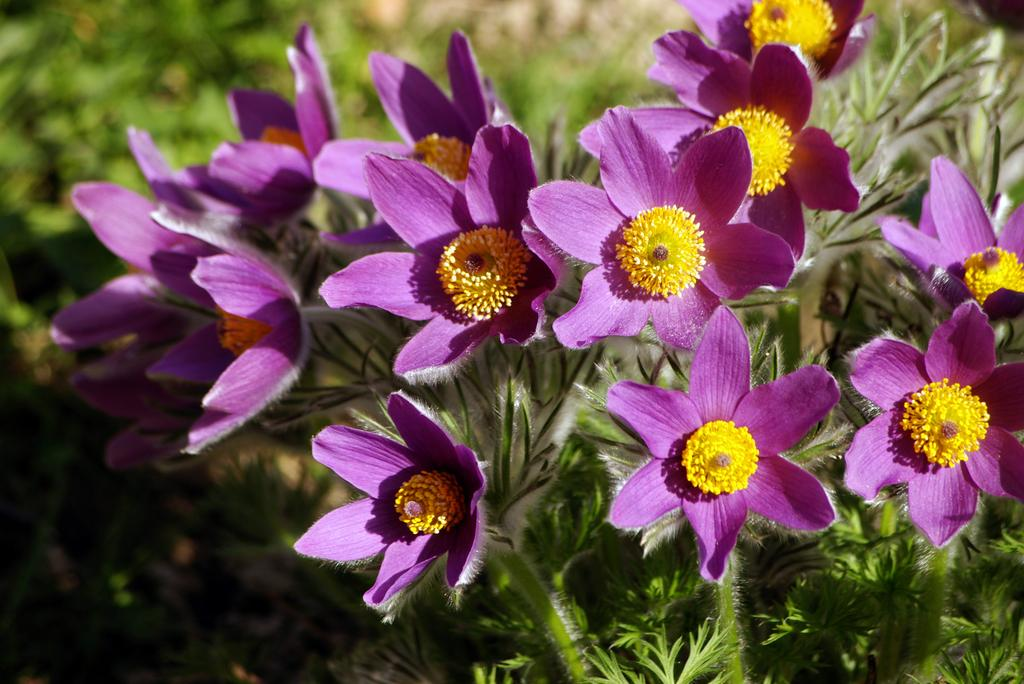What type of living organisms are present in the image? The image contains plants. What specific part of the plants can be seen in the image? There are flowers in the middle of the image. What colors are the flowers? The flowers are in yellow and violet colors. How many cakes are being served by the man in the image? There is no man or cakes present in the image; it features plants and flowers. 